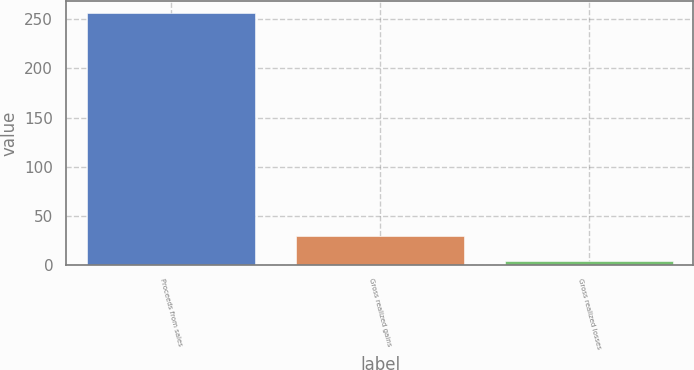Convert chart to OTSL. <chart><loc_0><loc_0><loc_500><loc_500><bar_chart><fcel>Proceeds from sales<fcel>Gross realized gains<fcel>Gross realized losses<nl><fcel>256<fcel>29.2<fcel>4<nl></chart> 